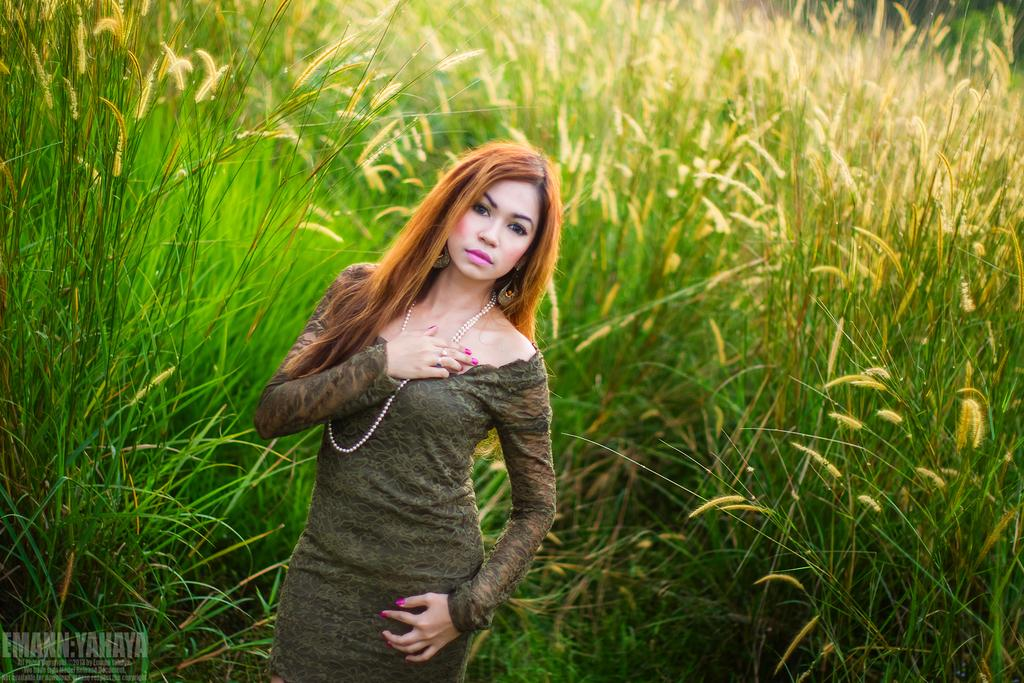Who or what is the main subject in the image? There is a person in the image. Can you describe the position of the person in the image? The person is in front of the image. What can be seen behind the person in the image? There is a food crop behind the person. What is present on the left side of the image? There is some text on the left side of the image. What type of root is being discussed by the person in the image? There is no indication in the image that the person is discussing any type of root. 